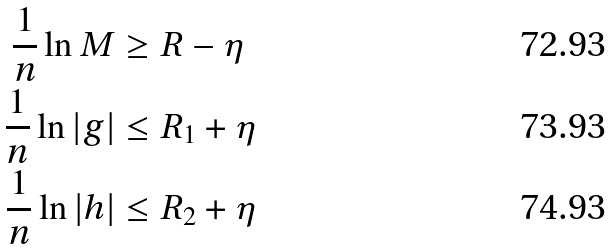<formula> <loc_0><loc_0><loc_500><loc_500>\frac { 1 } { n } \ln M & \geq R - \eta \\ \frac { 1 } { n } \ln | g | & \leq R _ { 1 } + \eta \\ \frac { 1 } { n } \ln | h | & \leq R _ { 2 } + \eta</formula> 